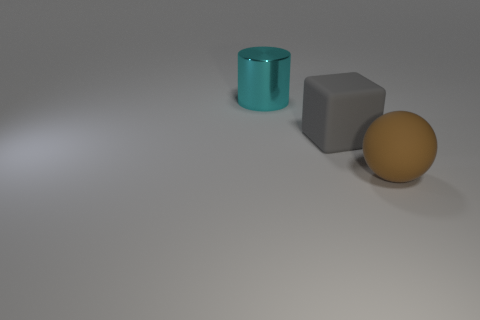Is the brown matte object the same shape as the large gray matte object?
Your response must be concise. No. There is a object to the left of the matte thing behind the brown sphere on the right side of the gray block; what is its size?
Provide a succinct answer. Large. How many objects are either big objects behind the big gray object or gray rubber cubes?
Offer a very short reply. 2. How many big metal objects are behind the rubber object to the right of the gray thing?
Keep it short and to the point. 1. Are there more cyan cylinders that are left of the brown matte thing than tiny red blocks?
Keep it short and to the point. Yes. The object that is both in front of the big cyan cylinder and to the left of the sphere has what shape?
Give a very brief answer. Cube. There is a matte object behind the large thing in front of the matte block; is there a big matte object that is in front of it?
Make the answer very short. Yes. What number of things are either large things to the left of the gray object or things that are in front of the big gray matte cube?
Give a very brief answer. 2. Is the material of the thing that is on the right side of the gray rubber cube the same as the gray block?
Offer a terse response. Yes. The thing behind the rubber thing that is behind the big brown matte thing is what color?
Your answer should be very brief. Cyan. 